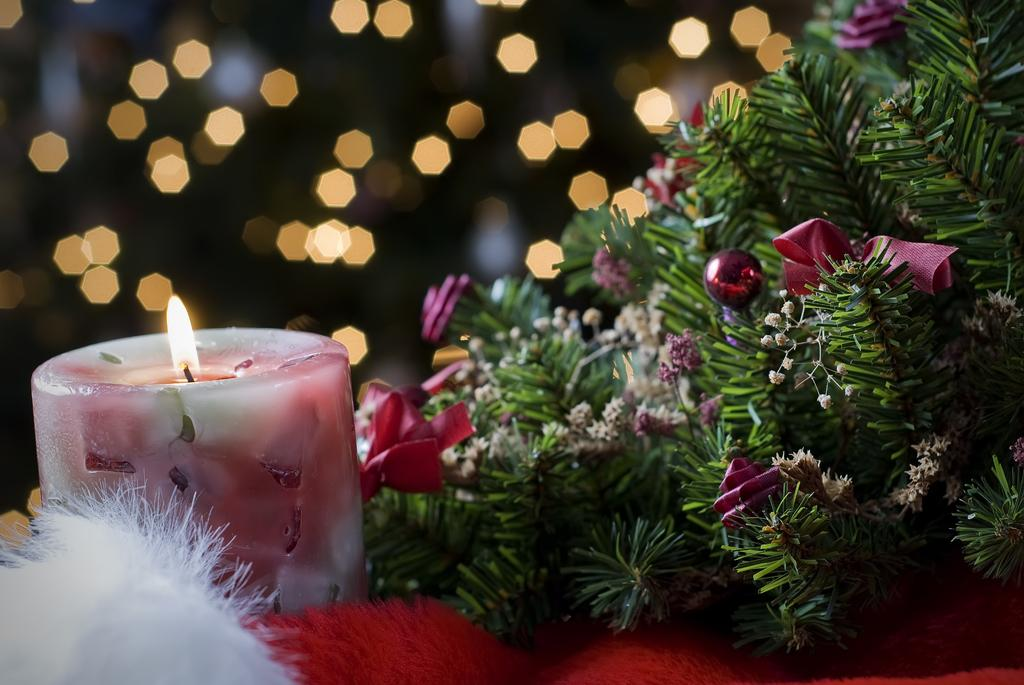What is the main object in the image? There is a candle in the image. What is another object related to the holiday season in the image? There is a Christmas tree in the image. What can be seen in the background of the image? There are lights visible in the background of the image. What type of stove is visible in the image? There is no stove present in the image. How does the grandfather contribute to the scene in the image? There is no grandfather present in the image. 